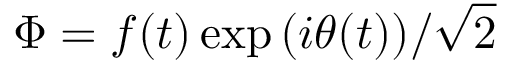<formula> <loc_0><loc_0><loc_500><loc_500>\Phi = f ( t ) \exp { ( i \theta ( t ) ) } / { \sqrt { 2 } }</formula> 